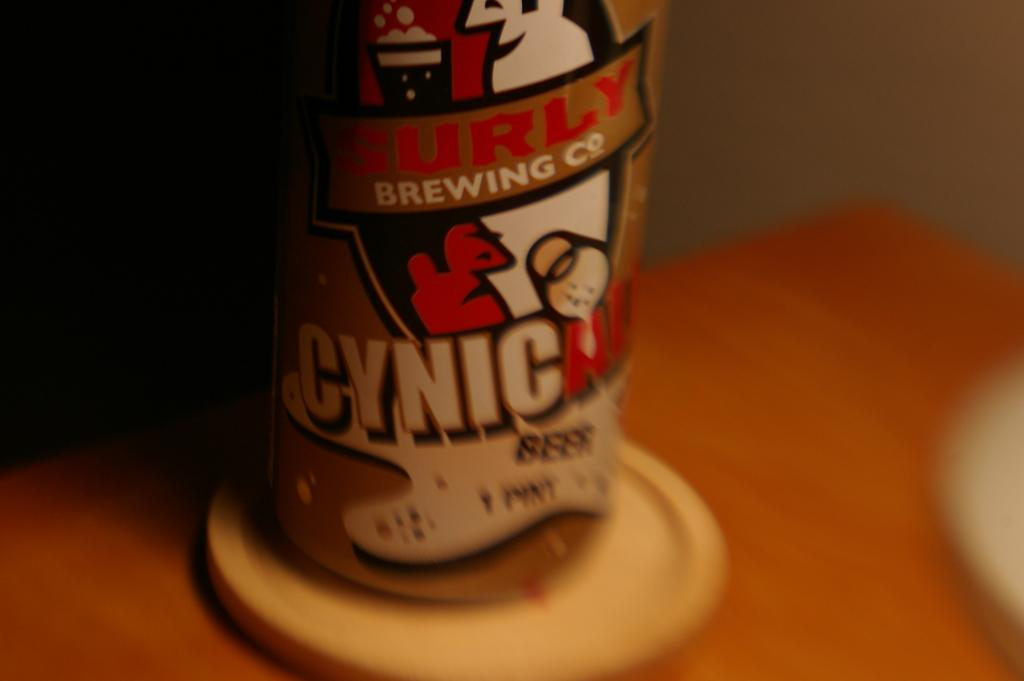<image>
Write a terse but informative summary of the picture. A can of Cynic beer by Burly Brewing Company. 